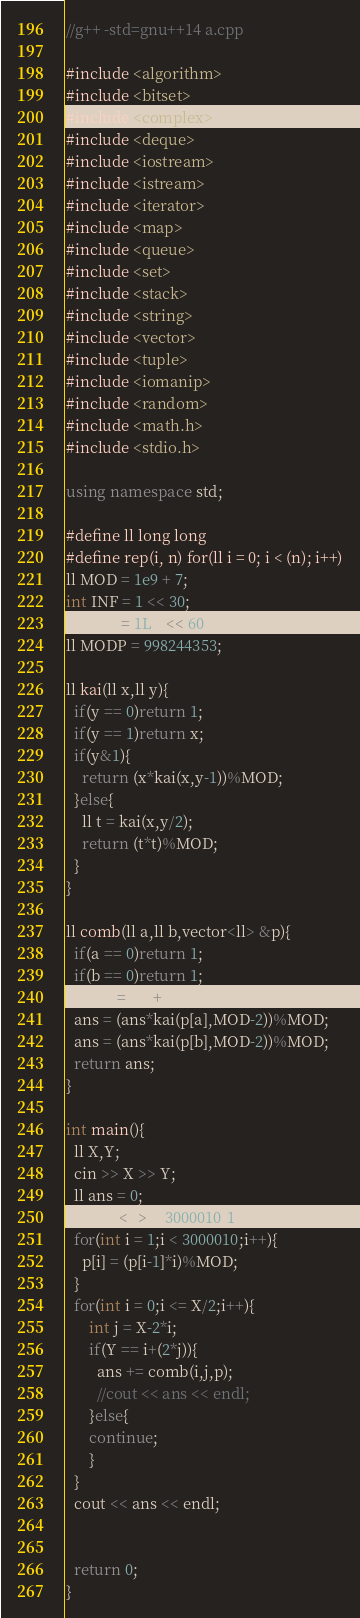Convert code to text. <code><loc_0><loc_0><loc_500><loc_500><_C++_>//g++ -std=gnu++14 a.cpp

#include <algorithm>
#include <bitset>
#include <complex>
#include <deque>
#include <iostream>
#include <istream>
#include <iterator>
#include <map>
#include <queue>
#include <set>
#include <stack>
#include <string>
#include <vector>
#include <tuple>
#include <iomanip>
#include <random>
#include <math.h>
#include <stdio.h>

using namespace std;

#define ll long long
#define rep(i, n) for(ll i = 0; i < (n); i++)
ll MOD = 1e9 + 7;
int INF = 1 << 30;
ll INFL = 1LL << 60;
ll MODP = 998244353;

ll kai(ll x,ll y){
  if(y == 0)return 1;
  if(y == 1)return x;
  if(y&1){
    return (x*kai(x,y-1))%MOD;
  }else{
    ll t = kai(x,y/2);
    return (t*t)%MOD;
  }
}

ll comb(ll a,ll b,vector<ll> &p){
  if(a == 0)return 1;
  if(b == 0)return 1;
  ll ans = p[a+b];
  ans = (ans*kai(p[a],MOD-2))%MOD;
  ans = (ans*kai(p[b],MOD-2))%MOD;
  return ans;
}

int main(){
  ll X,Y;
  cin >> X >> Y;
  ll ans = 0;
  vector<ll> p(3000010,1);
  for(int i = 1;i < 3000010;i++){
    p[i] = (p[i-1]*i)%MOD;
  }
  for(int i = 0;i <= X/2;i++){
      int j = X-2*i;
      if(Y == i+(2*j)){
        ans += comb(i,j,p);
        //cout << ans << endl;
      }else{
      continue;
      }
  }
  cout << ans << endl;


  return 0;
}
</code> 